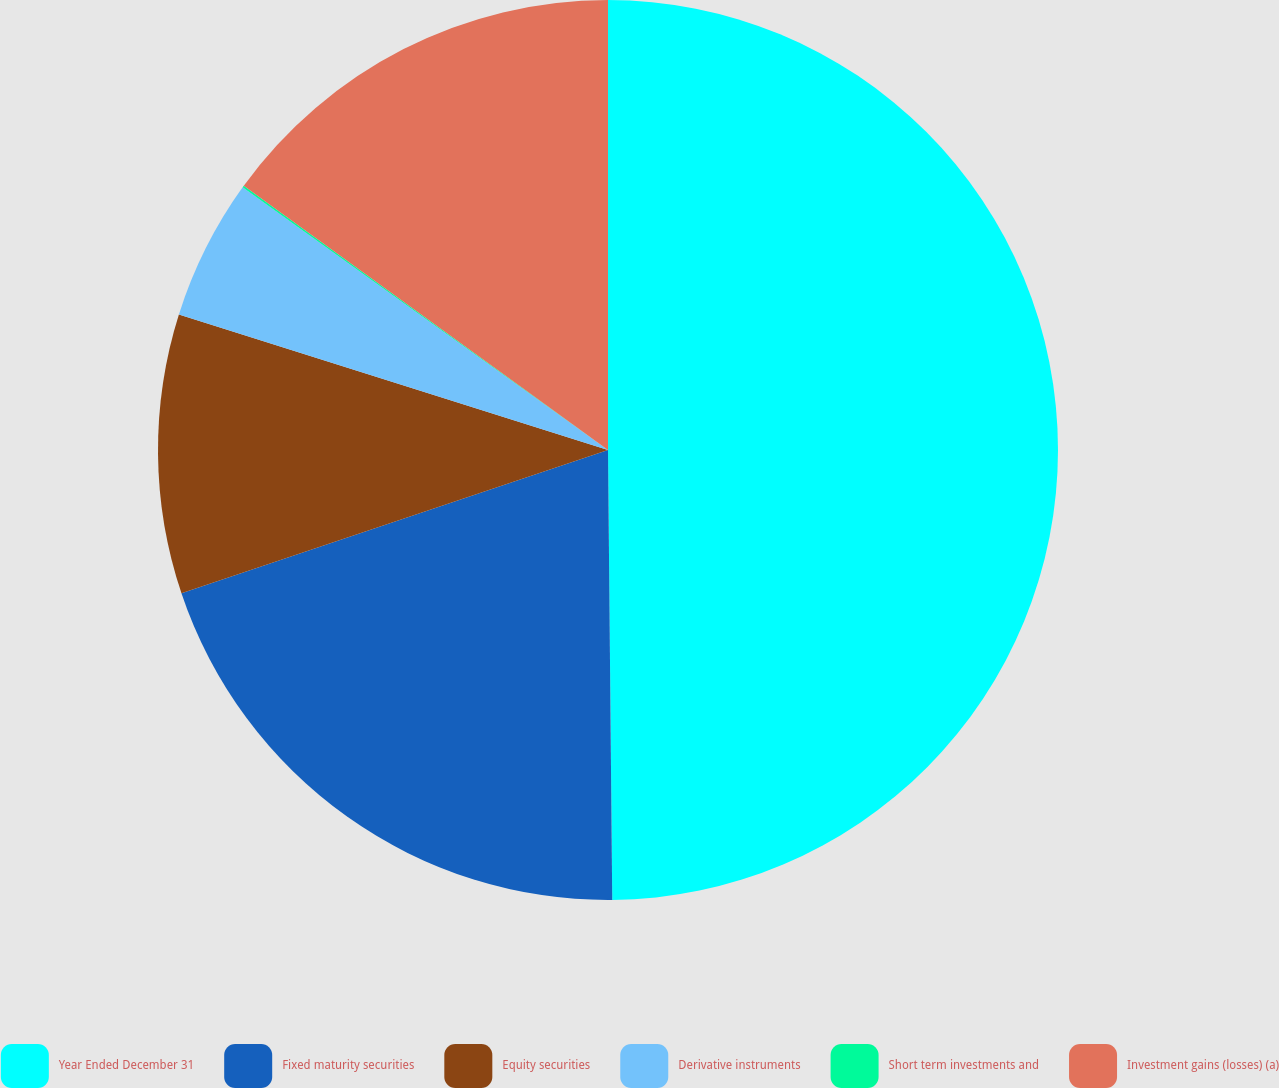<chart> <loc_0><loc_0><loc_500><loc_500><pie_chart><fcel>Year Ended December 31<fcel>Fixed maturity securities<fcel>Equity securities<fcel>Derivative instruments<fcel>Short term investments and<fcel>Investment gains (losses) (a)<nl><fcel>49.85%<fcel>19.99%<fcel>10.03%<fcel>5.05%<fcel>0.07%<fcel>15.01%<nl></chart> 